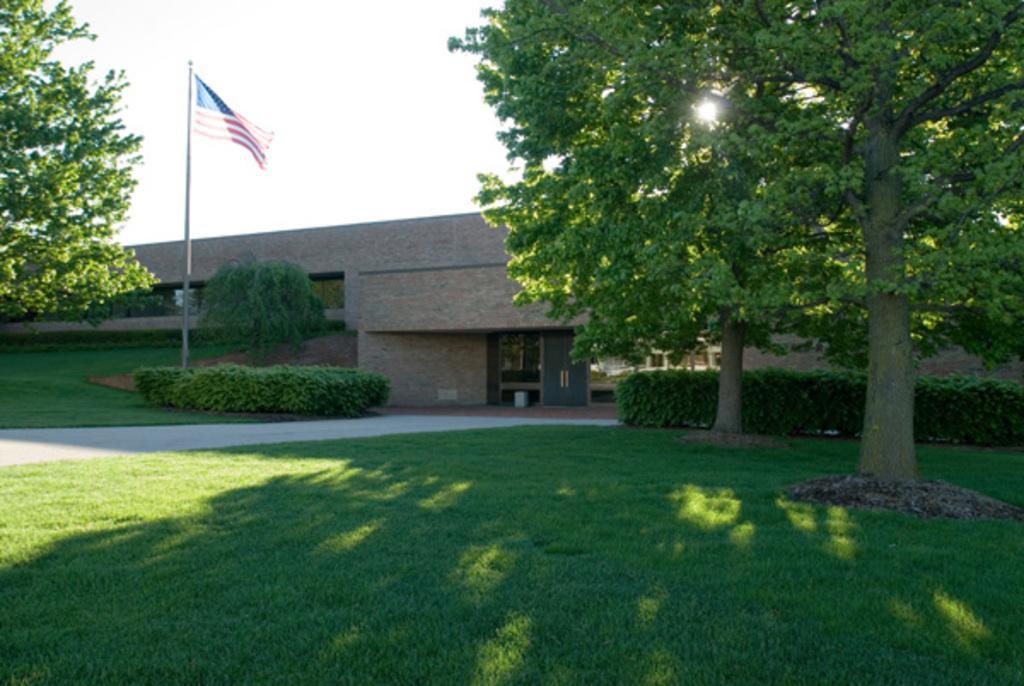Describe this image in one or two sentences. In this picture we can see building, in front we can see the flag, around we can see some trees and grass. 